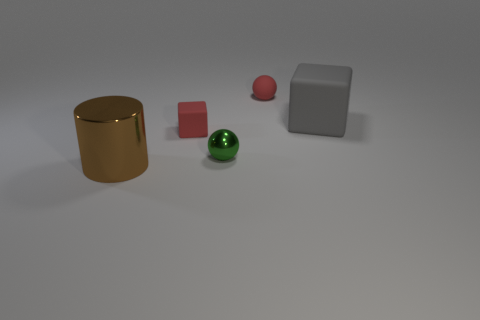Add 4 big brown cylinders. How many objects exist? 9 Subtract all cylinders. How many objects are left? 4 Subtract all small red spheres. Subtract all metal cylinders. How many objects are left? 3 Add 3 metal cylinders. How many metal cylinders are left? 4 Add 2 brown objects. How many brown objects exist? 3 Subtract 0 blue balls. How many objects are left? 5 